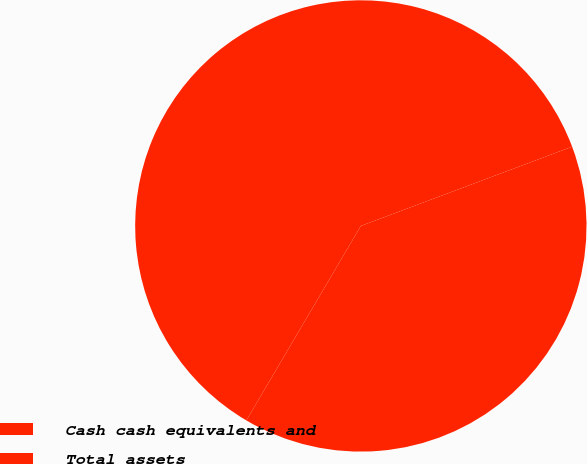Convert chart. <chart><loc_0><loc_0><loc_500><loc_500><pie_chart><fcel>Cash cash equivalents and<fcel>Total assets<nl><fcel>39.18%<fcel>60.82%<nl></chart> 